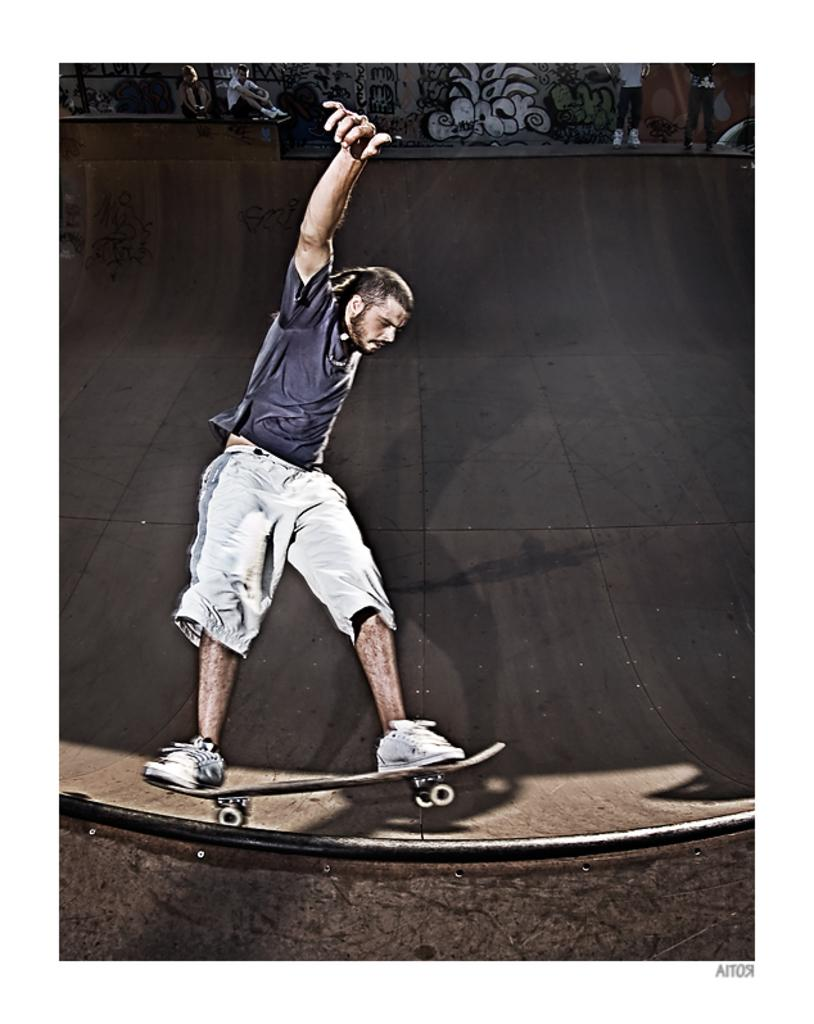What is the main subject of the image? The main subject of the image is a man. What is the man doing in the image? The man is standing on a skateboard and skating on a slide. Can you describe the background of the image? There are people visible in the background of the image. What type of skin condition can be seen on the man's face in the image? There is no indication of a skin condition on the man's face in the image. What kind of flame is visible in the image? There is no flame present in the image. 